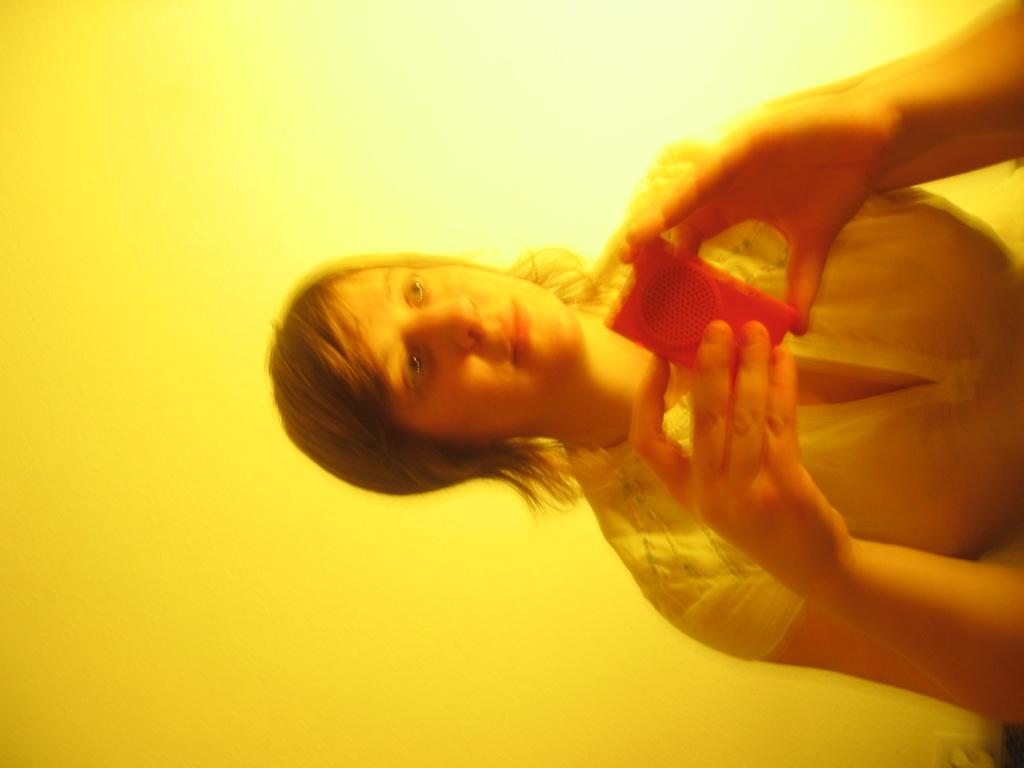Who is present in the image? There is a woman in the image. What is the woman holding in the image? The woman is holding an object. What can be seen in the background of the image? There is a wall in the background of the image. What type of stamp can be seen on the wall in the image? There is no stamp visible on the wall in the image. How many times does the woman fold the object she is holding in the image? The image does not show the woman folding the object, so it cannot be determined how many times she folds it. 